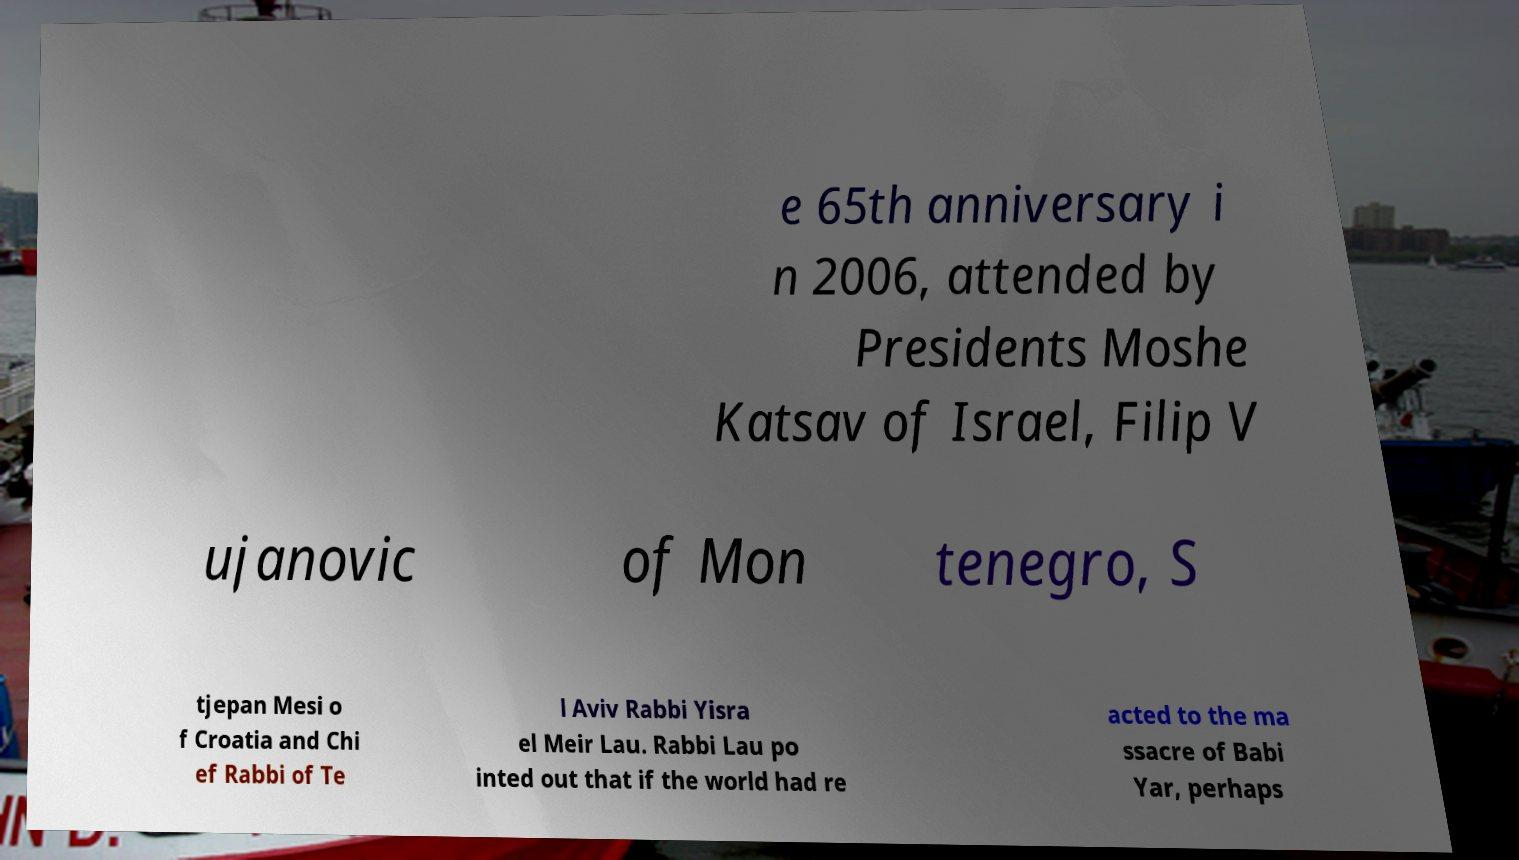Can you accurately transcribe the text from the provided image for me? e 65th anniversary i n 2006, attended by Presidents Moshe Katsav of Israel, Filip V ujanovic of Mon tenegro, S tjepan Mesi o f Croatia and Chi ef Rabbi of Te l Aviv Rabbi Yisra el Meir Lau. Rabbi Lau po inted out that if the world had re acted to the ma ssacre of Babi Yar, perhaps 